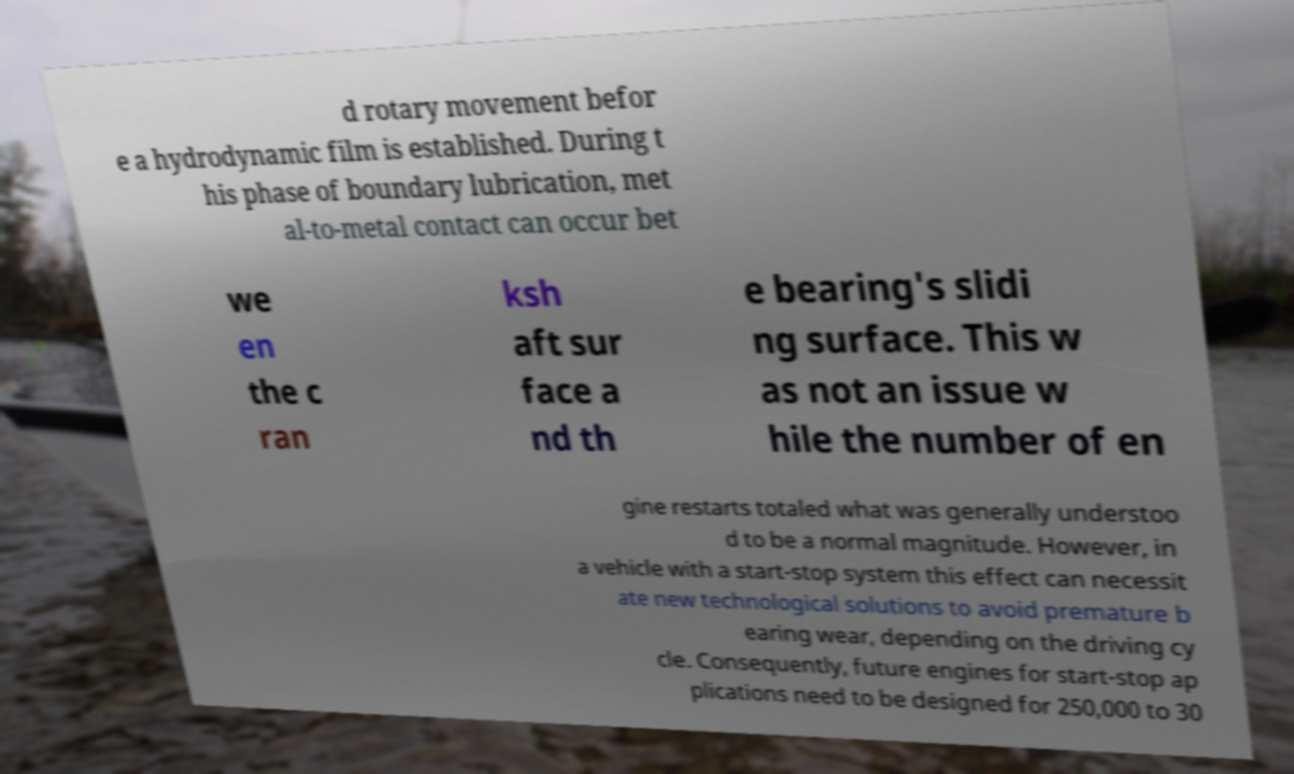There's text embedded in this image that I need extracted. Can you transcribe it verbatim? d rotary movement befor e a hydrodynamic film is established. During t his phase of boundary lubrication, met al-to-metal contact can occur bet we en the c ran ksh aft sur face a nd th e bearing's slidi ng surface. This w as not an issue w hile the number of en gine restarts totaled what was generally understoo d to be a normal magnitude. However, in a vehicle with a start-stop system this effect can necessit ate new technological solutions to avoid premature b earing wear, depending on the driving cy cle. Consequently, future engines for start-stop ap plications need to be designed for 250,000 to 30 